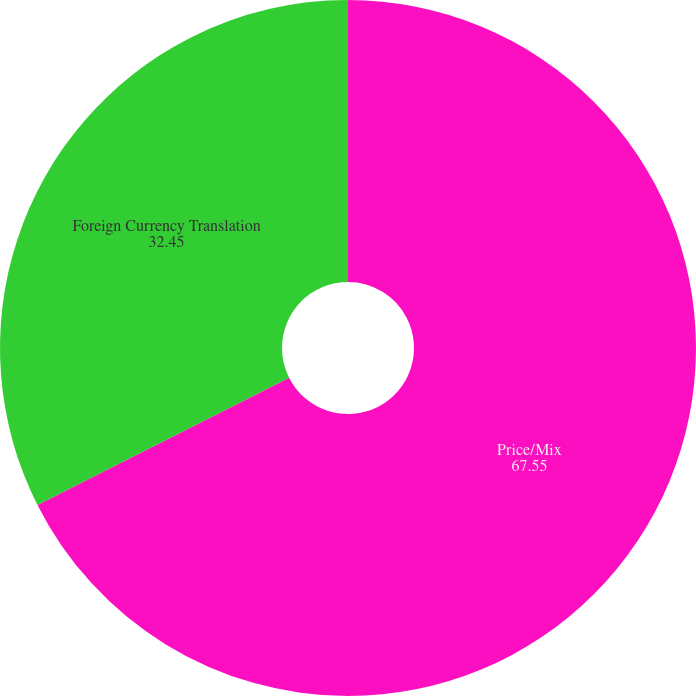<chart> <loc_0><loc_0><loc_500><loc_500><pie_chart><fcel>Price/Mix<fcel>Foreign Currency Translation<nl><fcel>67.55%<fcel>32.45%<nl></chart> 